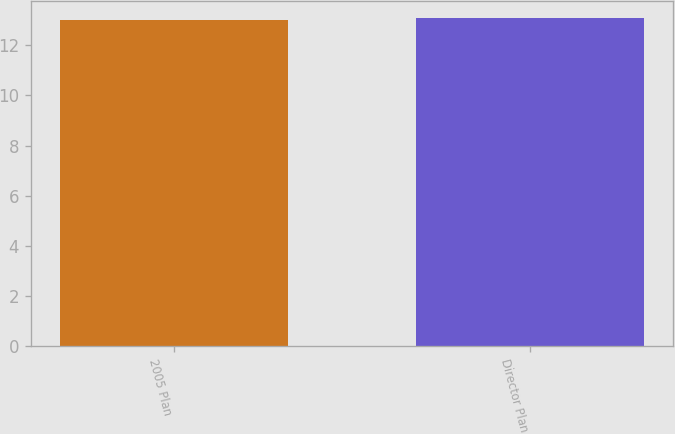Convert chart. <chart><loc_0><loc_0><loc_500><loc_500><bar_chart><fcel>2005 Plan<fcel>Director Plan<nl><fcel>13<fcel>13.1<nl></chart> 